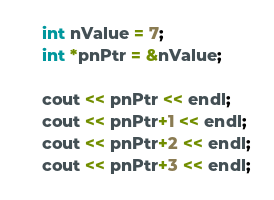Convert code to text. <code><loc_0><loc_0><loc_500><loc_500><_C++_>int nValue = 7;
int *pnPtr = &nValue;

cout << pnPtr << endl;
cout << pnPtr+1 << endl;
cout << pnPtr+2 << endl;
cout << pnPtr+3 << endl;</code> 